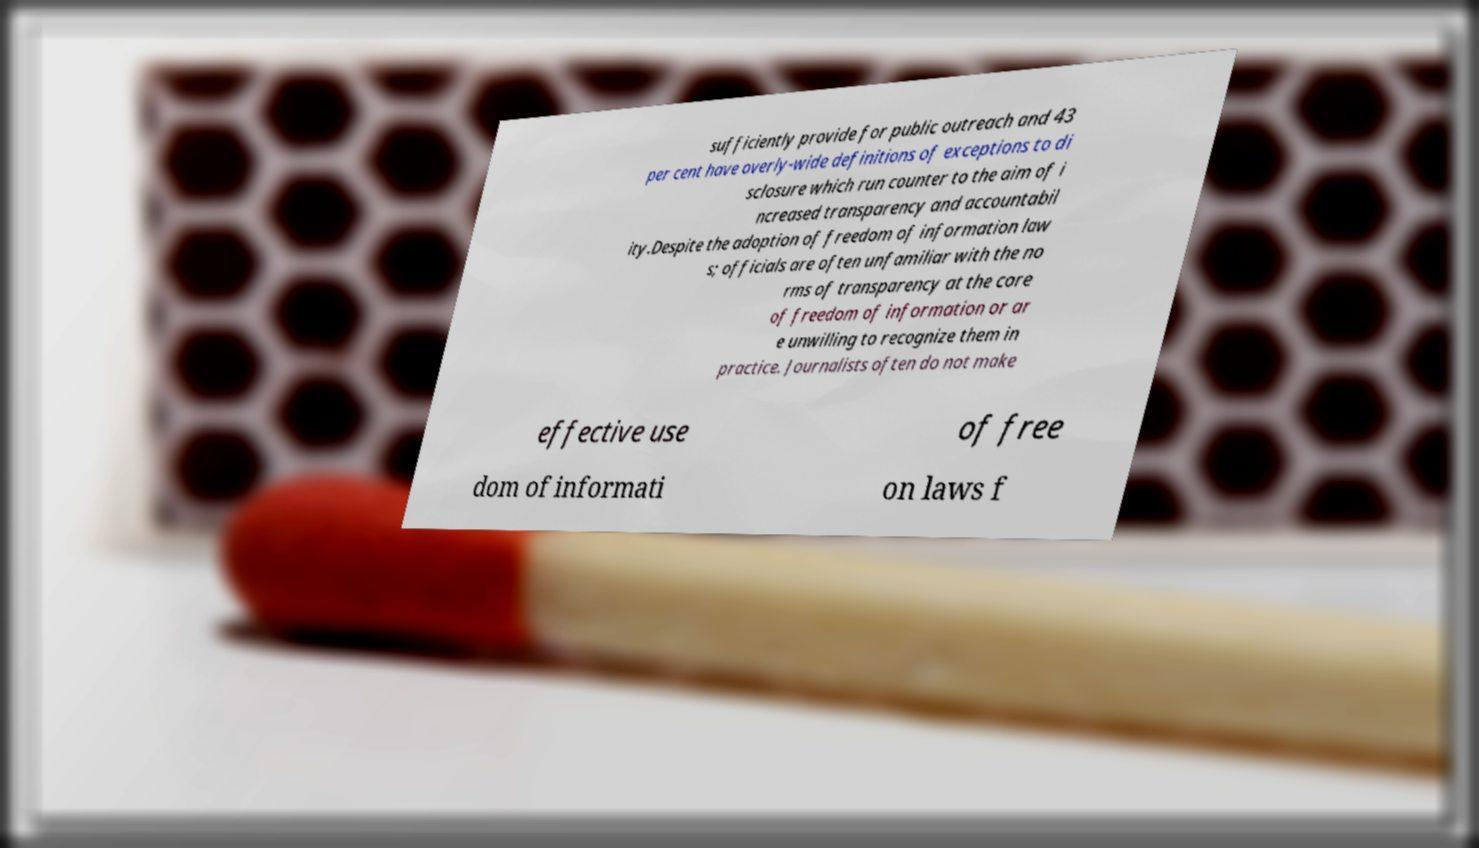There's text embedded in this image that I need extracted. Can you transcribe it verbatim? sufficiently provide for public outreach and 43 per cent have overly-wide definitions of exceptions to di sclosure which run counter to the aim of i ncreased transparency and accountabil ity.Despite the adoption of freedom of information law s; officials are often unfamiliar with the no rms of transparency at the core of freedom of information or ar e unwilling to recognize them in practice. Journalists often do not make effective use of free dom of informati on laws f 